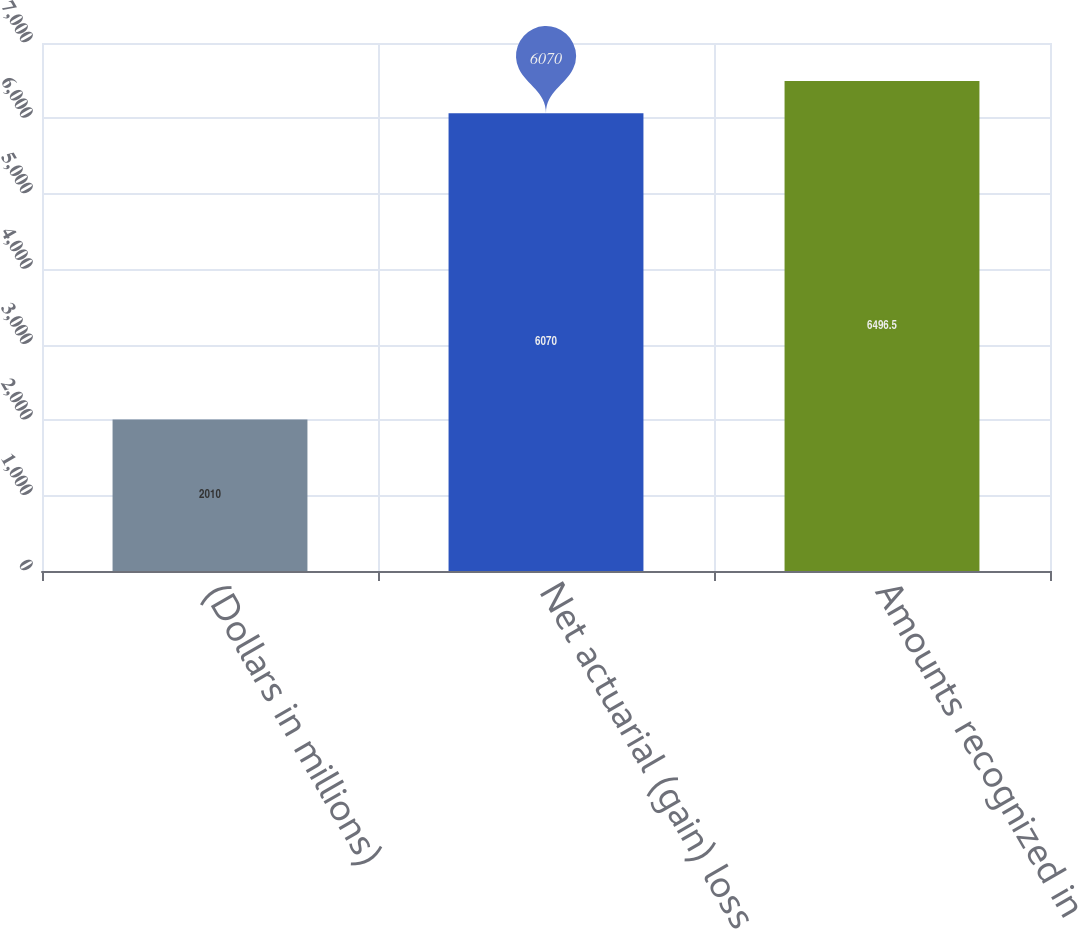Convert chart to OTSL. <chart><loc_0><loc_0><loc_500><loc_500><bar_chart><fcel>(Dollars in millions)<fcel>Net actuarial (gain) loss<fcel>Amounts recognized in<nl><fcel>2010<fcel>6070<fcel>6496.5<nl></chart> 